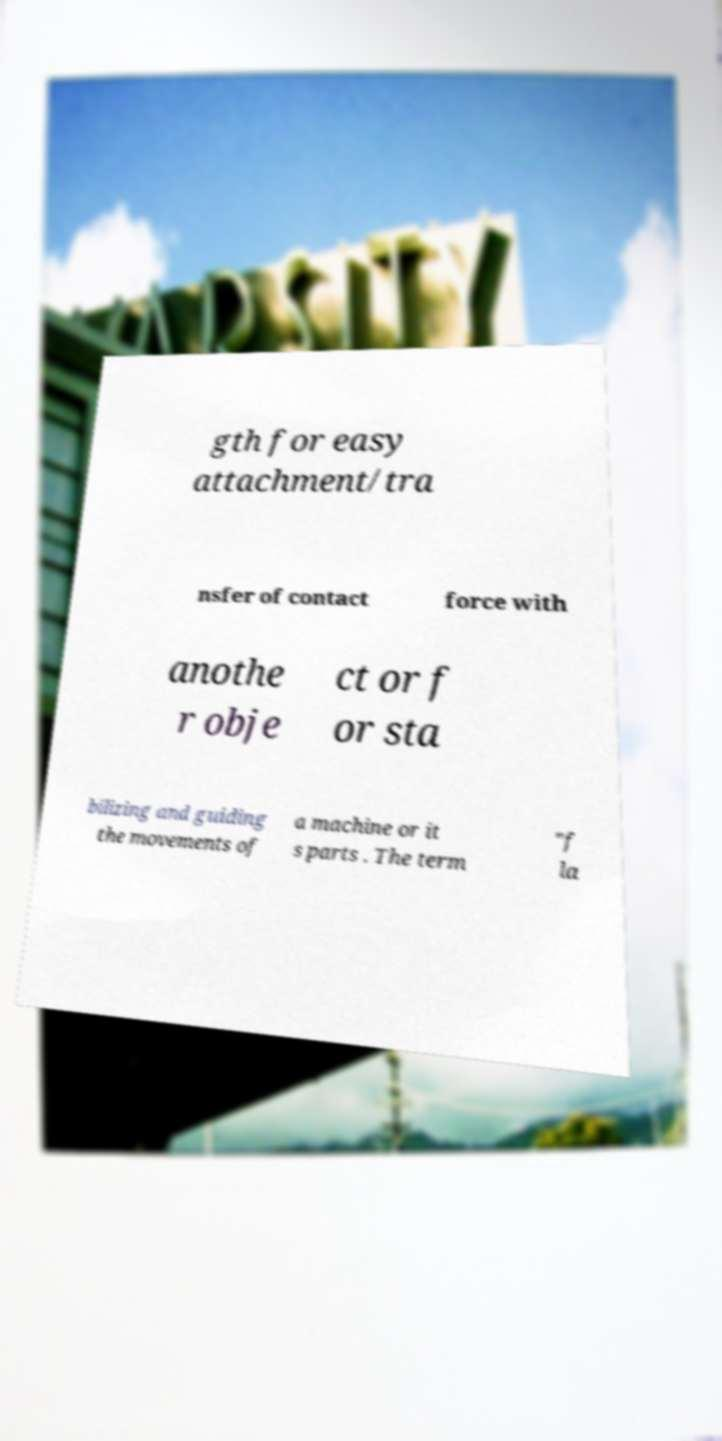There's text embedded in this image that I need extracted. Can you transcribe it verbatim? gth for easy attachment/tra nsfer of contact force with anothe r obje ct or f or sta bilizing and guiding the movements of a machine or it s parts . The term "f la 